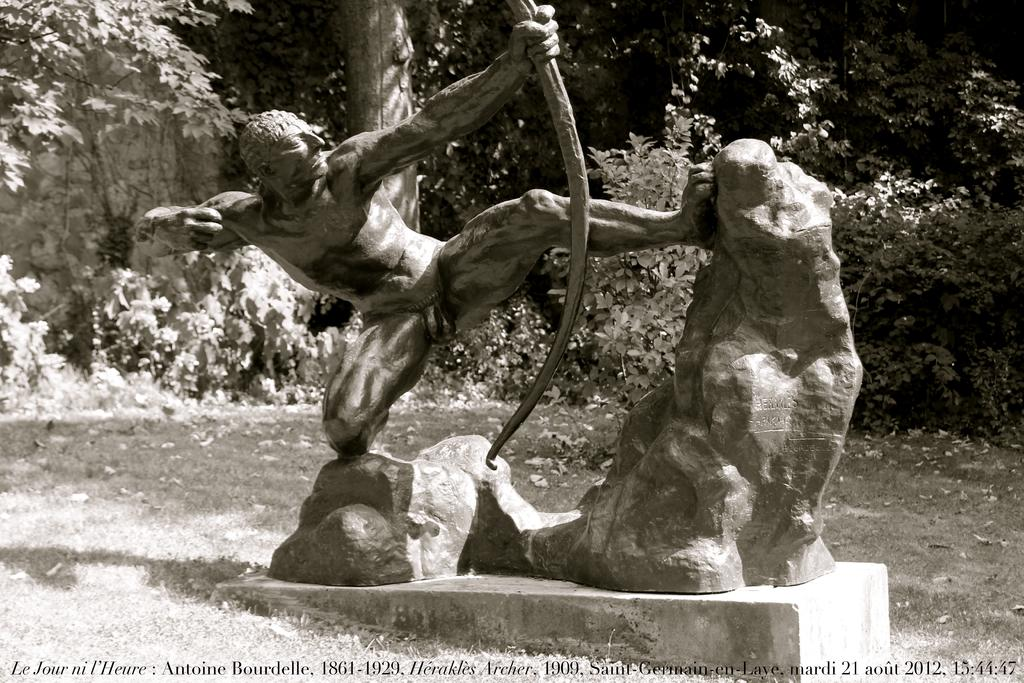What is the color scheme of the image? The image is black and white. What is the main subject in the image? There is a sculpture in the image. What can be seen in the background of the image? There are many trees behind the sculpture. How many pigs are visible in the image? There are no pigs present in the image. What type of camera is being used to take the picture? The image is black and white, but there is no information about the camera used to take the picture. 